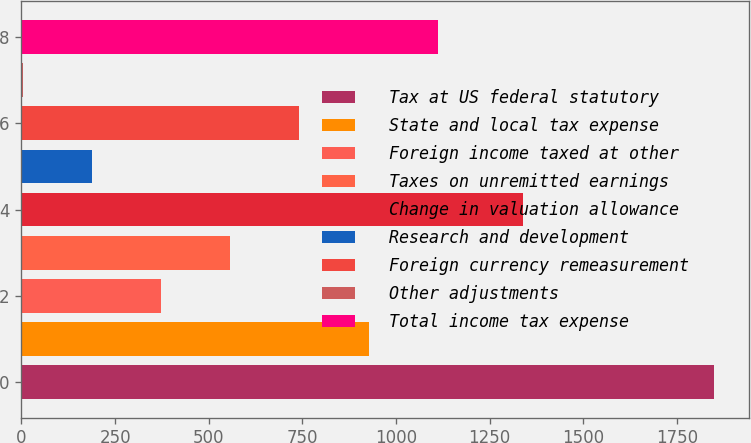<chart> <loc_0><loc_0><loc_500><loc_500><bar_chart><fcel>Tax at US federal statutory<fcel>State and local tax expense<fcel>Foreign income taxed at other<fcel>Taxes on unremitted earnings<fcel>Change in valuation allowance<fcel>Research and development<fcel>Foreign currency remeasurement<fcel>Other adjustments<fcel>Total income tax expense<nl><fcel>1849<fcel>926.5<fcel>373<fcel>557.5<fcel>1338<fcel>188.5<fcel>742<fcel>4<fcel>1111<nl></chart> 